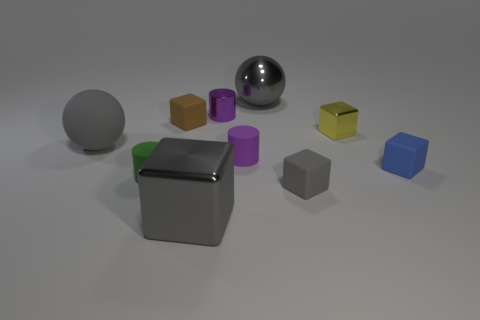Subtract all big gray metal cubes. How many cubes are left? 4 Add 8 big brown rubber cubes. How many big brown rubber cubes exist? 8 Subtract all green cylinders. How many cylinders are left? 2 Subtract 0 brown spheres. How many objects are left? 10 Subtract all cylinders. How many objects are left? 7 Subtract 1 balls. How many balls are left? 1 Subtract all blue balls. Subtract all purple blocks. How many balls are left? 2 Subtract all brown blocks. How many green cylinders are left? 1 Subtract all small green rubber cylinders. Subtract all yellow metallic things. How many objects are left? 8 Add 5 small metal cylinders. How many small metal cylinders are left? 6 